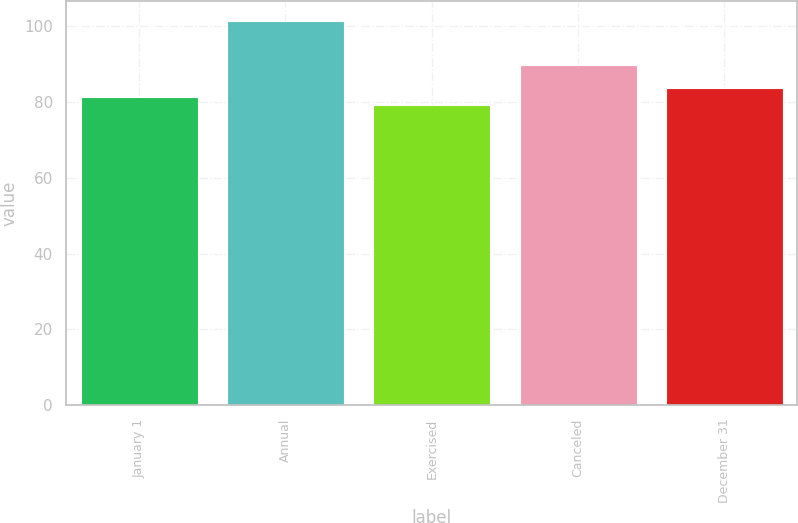Convert chart. <chart><loc_0><loc_0><loc_500><loc_500><bar_chart><fcel>January 1<fcel>Annual<fcel>Exercised<fcel>Canceled<fcel>December 31<nl><fcel>81.48<fcel>101.55<fcel>79.25<fcel>89.92<fcel>83.84<nl></chart> 